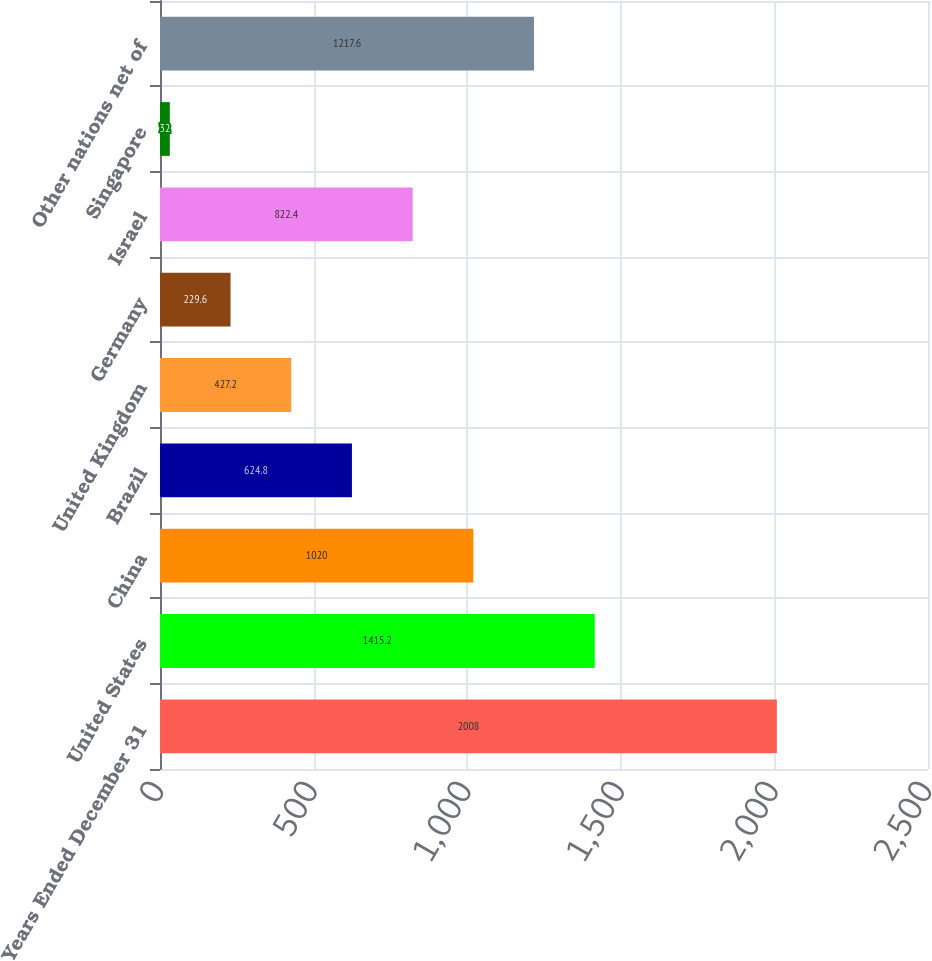Convert chart to OTSL. <chart><loc_0><loc_0><loc_500><loc_500><bar_chart><fcel>Years Ended December 31<fcel>United States<fcel>China<fcel>Brazil<fcel>United Kingdom<fcel>Germany<fcel>Israel<fcel>Singapore<fcel>Other nations net of<nl><fcel>2008<fcel>1415.2<fcel>1020<fcel>624.8<fcel>427.2<fcel>229.6<fcel>822.4<fcel>32<fcel>1217.6<nl></chart> 